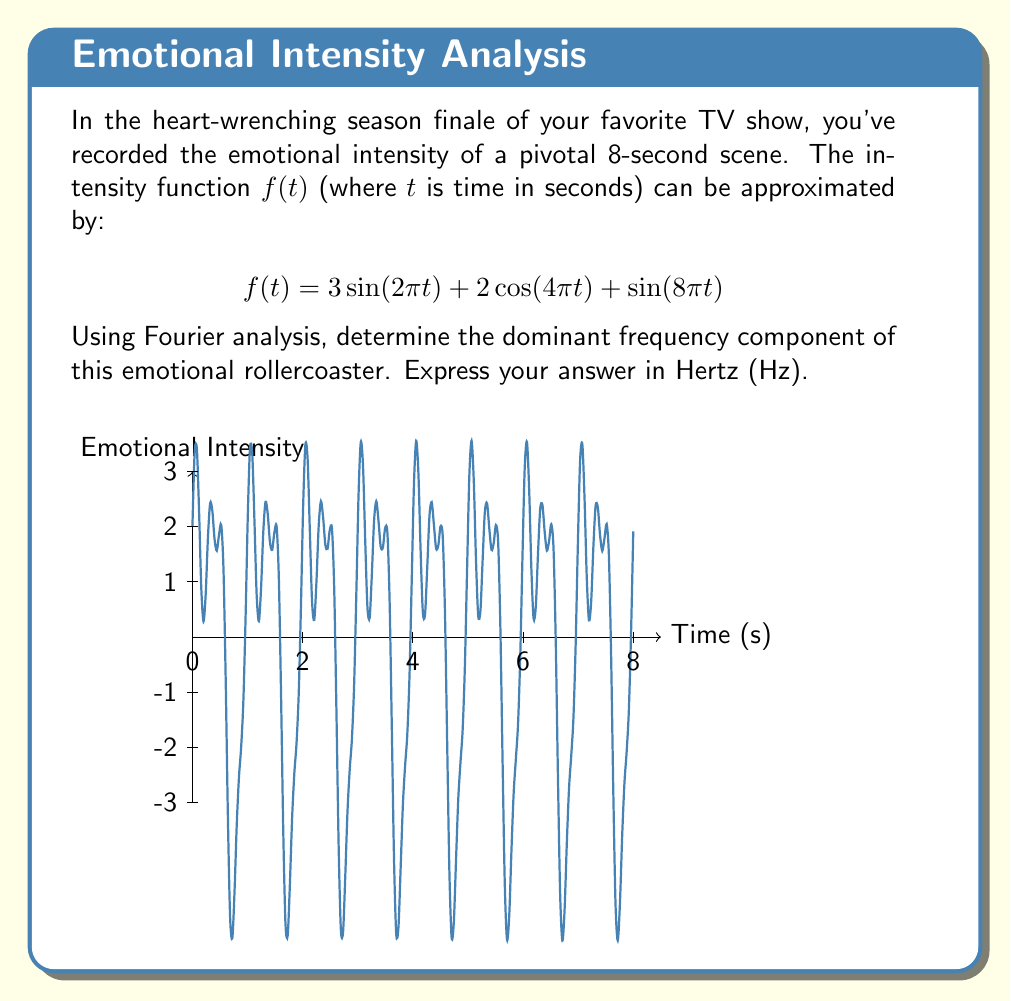Can you answer this question? Let's break this down step-by-step:

1) The Fourier transform decomposes a signal into its frequency components. In this case, we already have the signal expressed as a sum of sinusoids.

2) The general form of a sinusoid is $A\sin(2\pi ft)$ or $A\cos(2\pi ft)$, where $f$ is the frequency in Hz.

3) Let's identify the frequencies in our function:

   a) $3\sin(2\pi t)$: Here, $2\pi t = 2\pi ft$, so $f = 1$ Hz
   b) $2\cos(4\pi t)$: Here, $4\pi t = 2\pi ft$, so $f = 2$ Hz
   c) $\sin(8\pi t)$: Here, $8\pi t = 2\pi ft$, so $f = 4$ Hz

4) Now, we need to compare the amplitudes:
   a) 1 Hz component has amplitude 3
   b) 2 Hz component has amplitude 2
   c) 4 Hz component has amplitude 1

5) The dominant frequency is the one with the largest amplitude.

Therefore, the dominant frequency is 1 Hz, with an amplitude of 3.
Answer: 1 Hz 